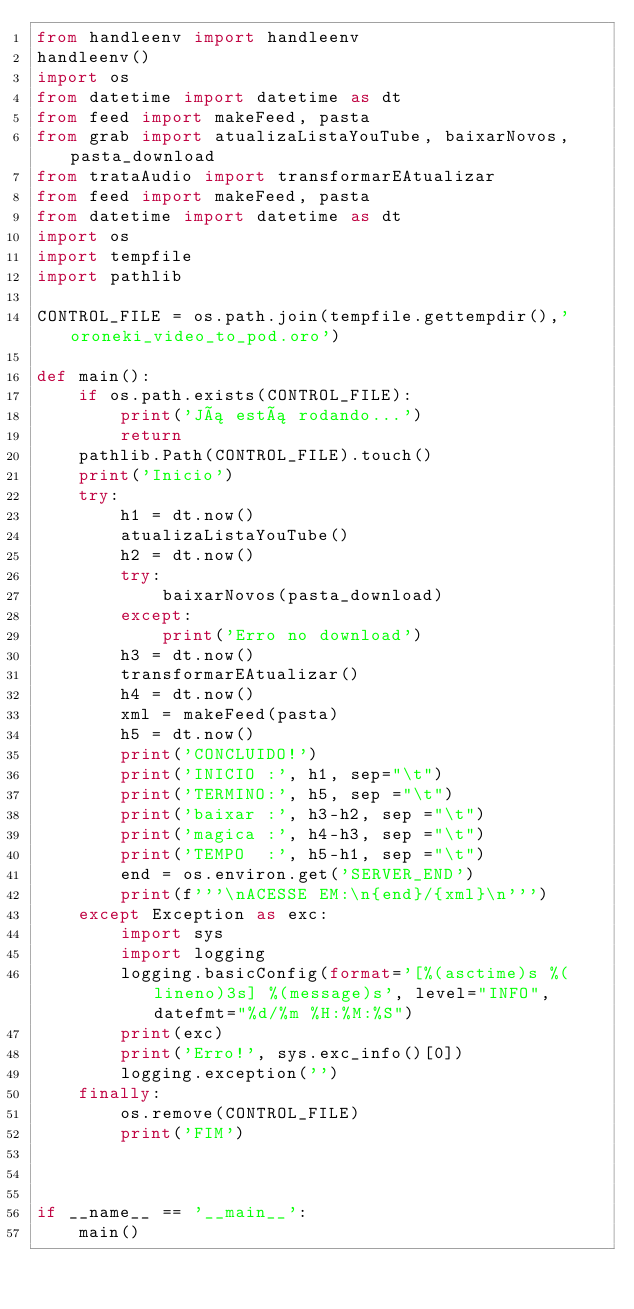<code> <loc_0><loc_0><loc_500><loc_500><_Python_>from handleenv import handleenv
handleenv()
import os
from datetime import datetime as dt
from feed import makeFeed, pasta
from grab import atualizaListaYouTube, baixarNovos, pasta_download
from trataAudio import transformarEAtualizar
from feed import makeFeed, pasta
from datetime import datetime as dt
import os
import tempfile
import pathlib

CONTROL_FILE = os.path.join(tempfile.gettempdir(),'oroneki_video_to_pod.oro')

def main():
    if os.path.exists(CONTROL_FILE):
        print('Já está rodando...')
        return
    pathlib.Path(CONTROL_FILE).touch()
    print('Inicio')
    try:
        h1 = dt.now()
        atualizaListaYouTube()
        h2 = dt.now()
        try:
            baixarNovos(pasta_download)
        except:
            print('Erro no download')    
        h3 = dt.now()
        transformarEAtualizar()
        h4 = dt.now()
        xml = makeFeed(pasta)
        h5 = dt.now()
        print('CONCLUIDO!')
        print('INICIO :', h1, sep="\t")
        print('TERMINO:', h5, sep ="\t")
        print('baixar :', h3-h2, sep ="\t")
        print('magica :', h4-h3, sep ="\t")
        print('TEMPO  :', h5-h1, sep ="\t")
        end = os.environ.get('SERVER_END')
        print(f'''\nACESSE EM:\n{end}/{xml}\n''')
    except Exception as exc:
        import sys
        import logging
        logging.basicConfig(format='[%(asctime)s %(lineno)3s] %(message)s', level="INFO", datefmt="%d/%m %H:%M:%S")
        print(exc)
        print('Erro!', sys.exc_info()[0])
        logging.exception('')
    finally:
        os.remove(CONTROL_FILE)
        print('FIM')
        


if __name__ == '__main__':
    main()
</code> 